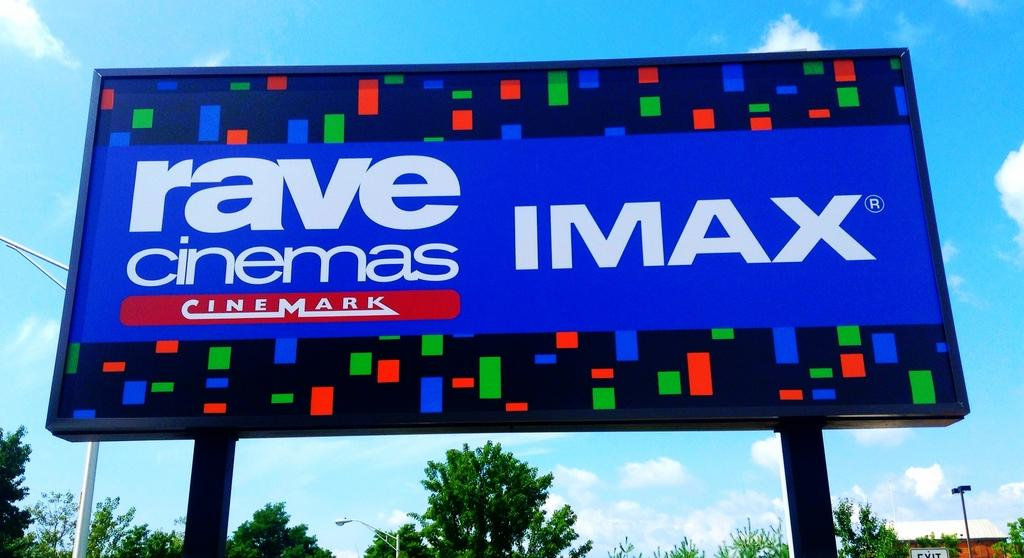<image>
Write a terse but informative summary of the picture. A large sign advertises IMAX theaters at Rave Cinemas. 